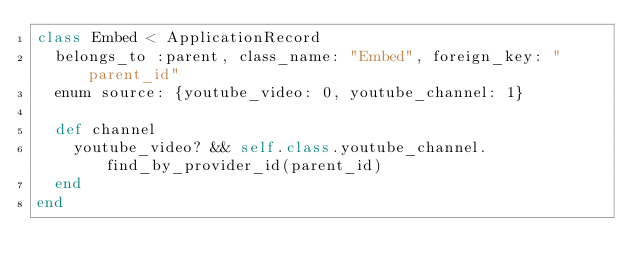<code> <loc_0><loc_0><loc_500><loc_500><_Ruby_>class Embed < ApplicationRecord
  belongs_to :parent, class_name: "Embed", foreign_key: "parent_id"
  enum source: {youtube_video: 0, youtube_channel: 1}
  
  def channel
    youtube_video? && self.class.youtube_channel.find_by_provider_id(parent_id)
  end
end
</code> 